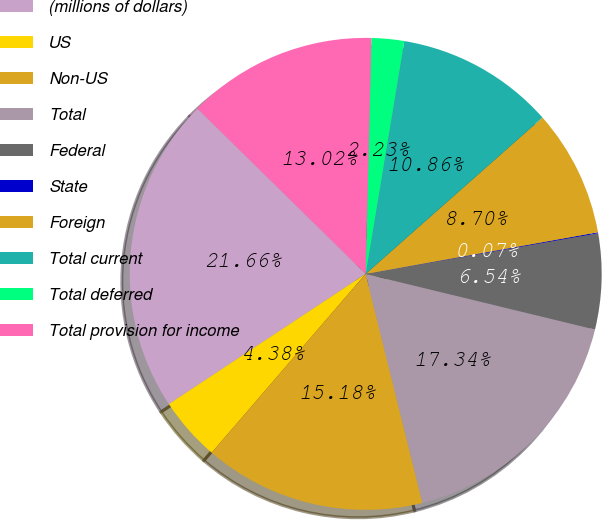<chart> <loc_0><loc_0><loc_500><loc_500><pie_chart><fcel>(millions of dollars)<fcel>US<fcel>Non-US<fcel>Total<fcel>Federal<fcel>State<fcel>Foreign<fcel>Total current<fcel>Total deferred<fcel>Total provision for income<nl><fcel>21.66%<fcel>4.38%<fcel>15.18%<fcel>17.34%<fcel>6.54%<fcel>0.07%<fcel>8.7%<fcel>10.86%<fcel>2.23%<fcel>13.02%<nl></chart> 